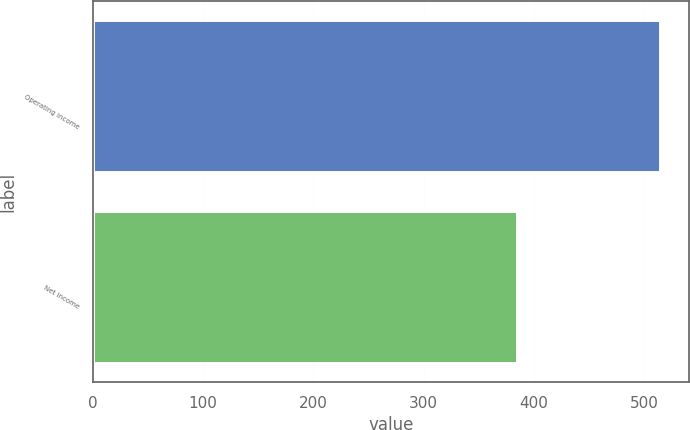<chart> <loc_0><loc_0><loc_500><loc_500><bar_chart><fcel>Operating income<fcel>Net income<nl><fcel>515<fcel>385<nl></chart> 